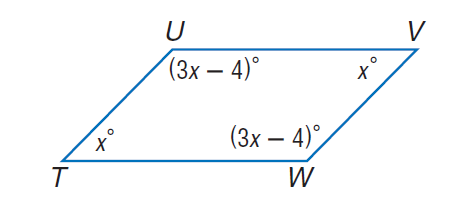Answer the mathemtical geometry problem and directly provide the correct option letter.
Question: Find m \angle T.
Choices: A: 44 B: 46 C: 54 D: 134 B 